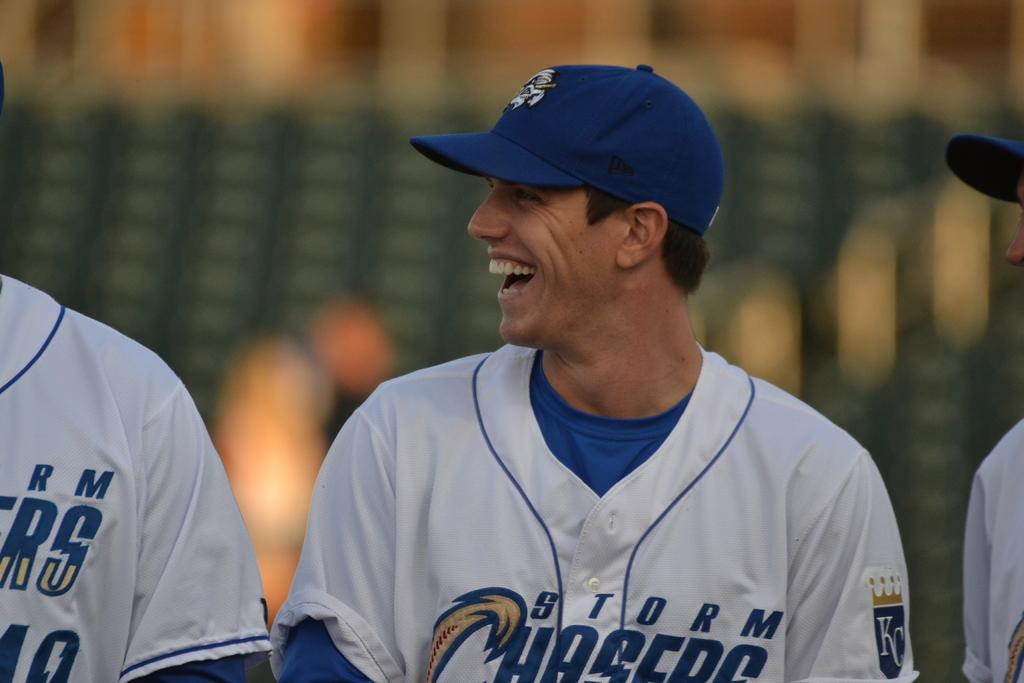Provide a one-sentence caption for the provided image. The baseball team shown here is called the Storm Chasers. 